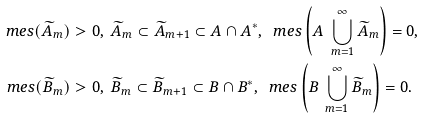<formula> <loc_0><loc_0><loc_500><loc_500>\ m e s ( \widetilde { A } _ { m } ) & > 0 , \ \widetilde { A } _ { m } \subset \widetilde { A } _ { m + 1 } \subset A \cap A ^ { \ast } , \ \ m e s \left ( A \ \bigcup _ { m = 1 } ^ { \infty } \widetilde { A } _ { m } \right ) = 0 , \\ \ m e s ( \widetilde { B } _ { m } ) & > 0 , \ \widetilde { B } _ { m } \subset \widetilde { B } _ { m + 1 } \subset B \cap B ^ { \ast } , \ \ m e s \left ( B \ \bigcup _ { m = 1 } ^ { \infty } \widetilde { B } _ { m } \right ) = 0 .</formula> 